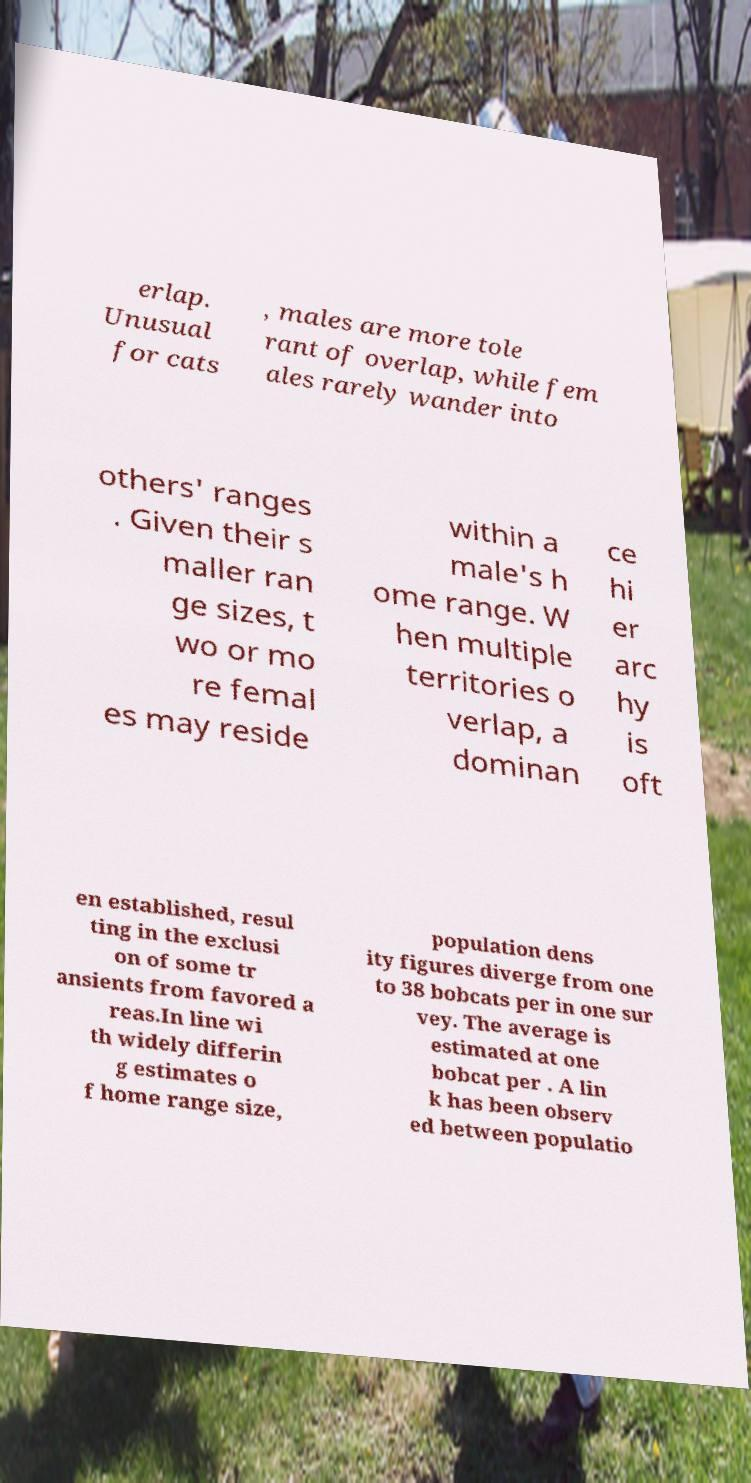Could you assist in decoding the text presented in this image and type it out clearly? erlap. Unusual for cats , males are more tole rant of overlap, while fem ales rarely wander into others' ranges . Given their s maller ran ge sizes, t wo or mo re femal es may reside within a male's h ome range. W hen multiple territories o verlap, a dominan ce hi er arc hy is oft en established, resul ting in the exclusi on of some tr ansients from favored a reas.In line wi th widely differin g estimates o f home range size, population dens ity figures diverge from one to 38 bobcats per in one sur vey. The average is estimated at one bobcat per . A lin k has been observ ed between populatio 